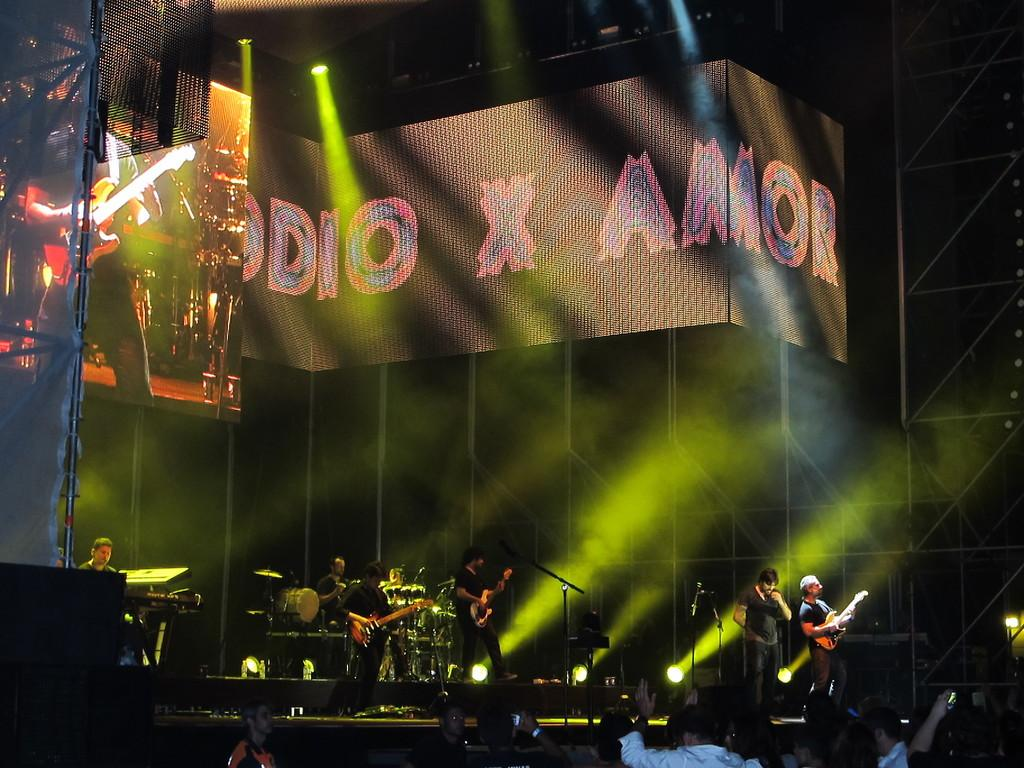What is happening in the image? There are people standing in the image, and there is a stage in the background where people are playing musical instruments. What can be seen behind the people playing musical instruments? There are screens behind the people playing musical instruments. What else is visible in the image? There are lights visible in the image. Can you describe the setting of the image? The setting appears to be a performance or concert, with people standing and watching the musicians on stage. What type of chicken is being used as an attraction in the image? There is no chicken present in the image, and therefore no such attraction can be observed. What health benefits are associated with the lights visible in the image? The image does not provide any information about the health benefits of the lights; it simply shows their presence. 